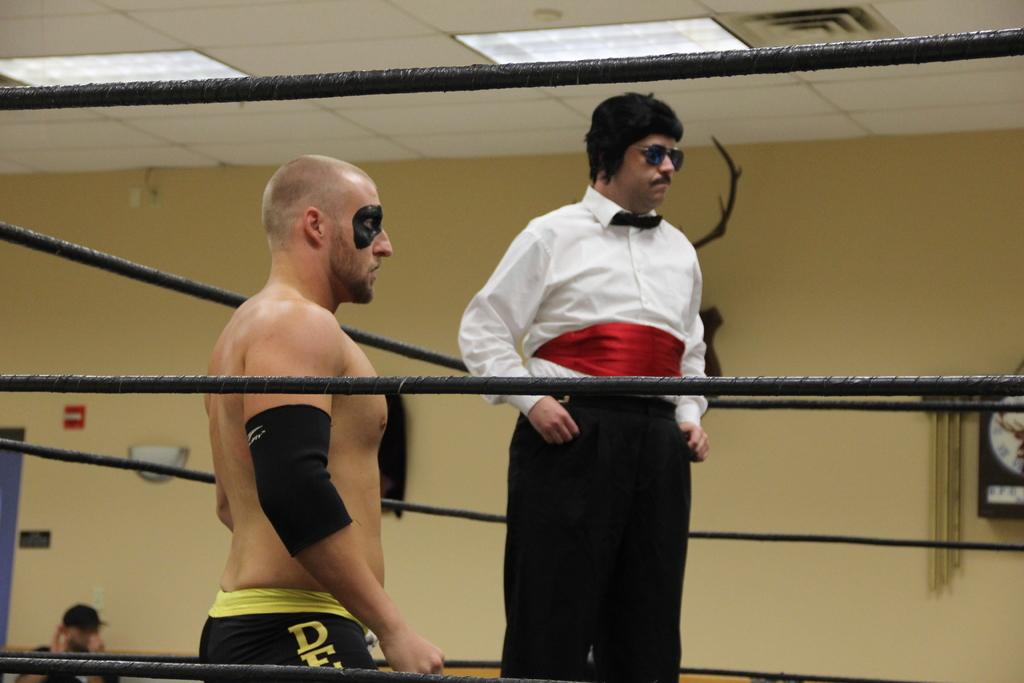How many people are in the image? There are two members in the image. What are the two members doing in the image? The two members are standing in a boxing ring. What can be seen in the background of the image? There is a wall visible in the background of the image. What type of party is being held in the boxing ring in the image? There is no party being held in the boxing ring in the image; it simply shows two members standing in the ring. How many spiders are crawling on the wall in the background of the image? There are no spiders visible in the image, so it is not possible to determine their number. 